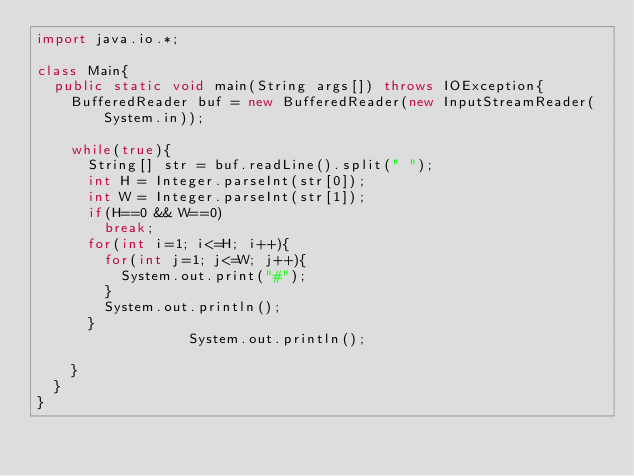Convert code to text. <code><loc_0><loc_0><loc_500><loc_500><_Java_>import java.io.*;

class Main{
	public static void main(String args[]) throws IOException{
		BufferedReader buf = new BufferedReader(new InputStreamReader(System.in));
		
		while(true){
			String[] str = buf.readLine().split(" ");
			int H = Integer.parseInt(str[0]);
			int W = Integer.parseInt(str[1]);
			if(H==0 && W==0)
				break;
			for(int i=1; i<=H; i++){
				for(int j=1; j<=W; j++){
					System.out.print("#");
				}
				System.out.println();
			}
                  System.out.println();
      
		}
	}	
}</code> 